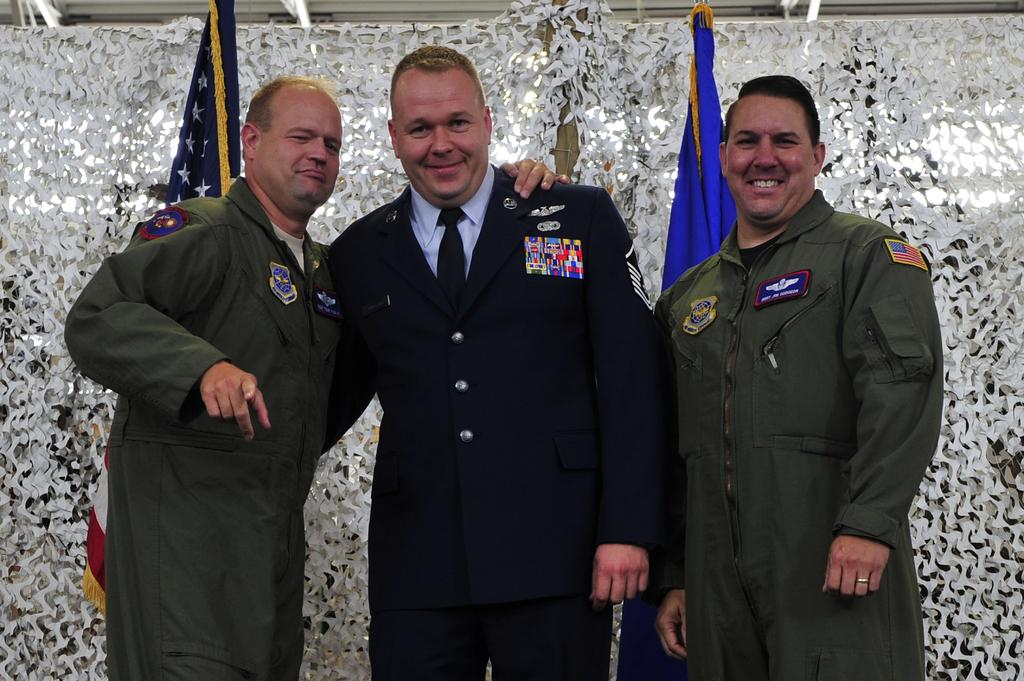How many people are in the image? There are three persons in the image. What is the facial expression of the people in the image? The persons are smiling. What can be seen in the background of the image? There are flags and an object in the background of the image. What is the acoustics like in the image? There is no information about the acoustics in the image, as it does not involve any sounds or audible elements. 